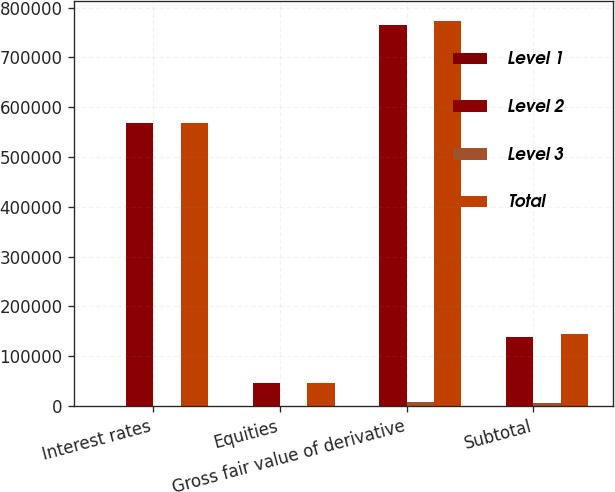Convert chart. <chart><loc_0><loc_0><loc_500><loc_500><stacked_bar_chart><ecel><fcel>Interest rates<fcel>Equities<fcel>Gross fair value of derivative<fcel>Subtotal<nl><fcel>Level 1<fcel>4<fcel>46<fcel>50<fcel>50<nl><fcel>Level 2<fcel>567761<fcel>46491<fcel>766130<fcel>138582<nl><fcel>Level 3<fcel>560<fcel>623<fcel>8009<fcel>5870<nl><fcel>Total<fcel>568325<fcel>47160<fcel>774189<fcel>144502<nl></chart> 